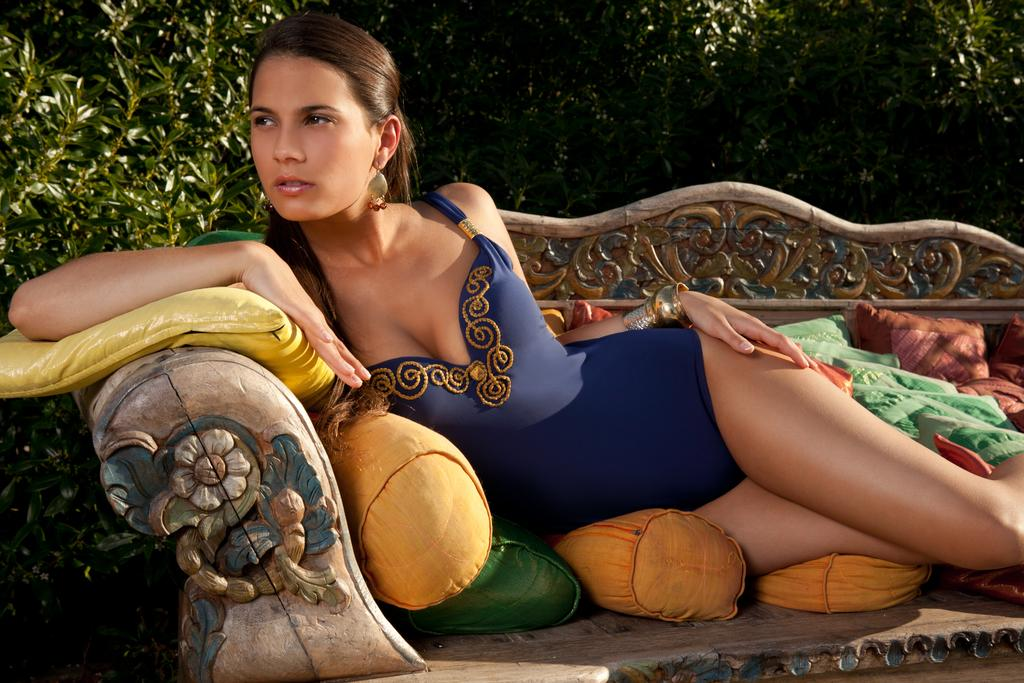Who is the main subject in the image? There is a woman in the image. What is the woman wearing? The woman is wearing a blue dress. What is the woman doing in the image? The woman is laying on a bench. Which direction is the woman looking? The woman is looking at the left side. What is supporting the woman's comfort on the bench? There are pillows on the bench. What can be seen in the background of the image? There are trees in the background of the image. What type of agreement is being discussed by the woman in the image? There is no indication in the image that the woman is discussing any agreement; she is simply laying on a bench and looking to the left side. 